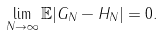<formula> <loc_0><loc_0><loc_500><loc_500>\lim _ { N \to \infty } \mathbb { E } | G _ { N } - H _ { N } | = 0 .</formula> 